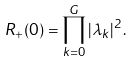<formula> <loc_0><loc_0><loc_500><loc_500>R _ { + } ( 0 ) = \prod _ { k = 0 } ^ { G } | \lambda _ { k } | ^ { 2 } \, .</formula> 